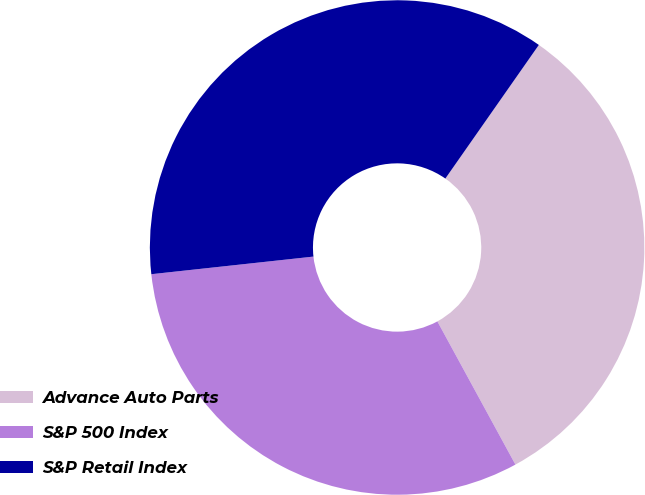Convert chart to OTSL. <chart><loc_0><loc_0><loc_500><loc_500><pie_chart><fcel>Advance Auto Parts<fcel>S&P 500 Index<fcel>S&P Retail Index<nl><fcel>32.34%<fcel>31.22%<fcel>36.44%<nl></chart> 